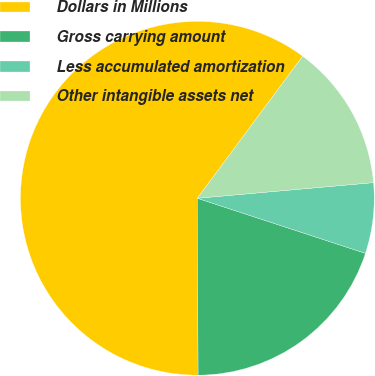<chart> <loc_0><loc_0><loc_500><loc_500><pie_chart><fcel>Dollars in Millions<fcel>Gross carrying amount<fcel>Less accumulated amortization<fcel>Other intangible assets net<nl><fcel>60.22%<fcel>19.89%<fcel>6.45%<fcel>13.44%<nl></chart> 